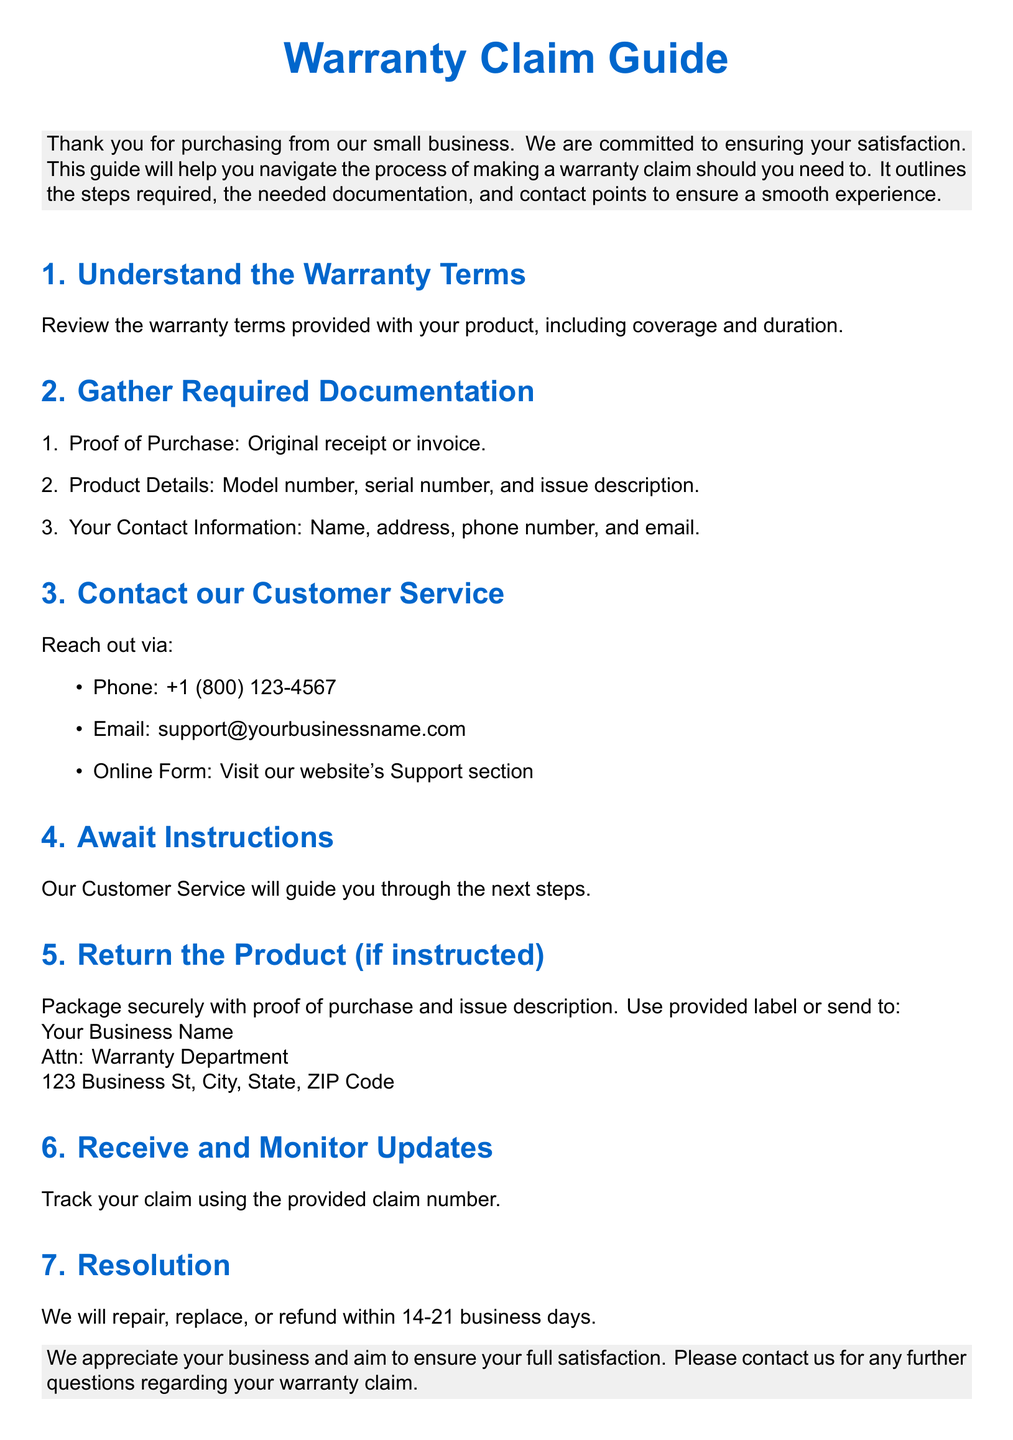What is the first step in making a warranty claim? The first step in making a warranty claim is to review the warranty terms provided with your product.
Answer: Understand the Warranty Terms What contact methods are provided for customer service? The document lists phone, email, and an online form as contact methods for customer service.
Answer: Phone, Email, Online Form How long will it take to receive a resolution to the claim? The document states that the resolution will be provided within 14-21 business days after the claim is submitted.
Answer: 14-21 business days What information is included in the required documentation? The required documentation includes proof of purchase, product details, and your contact information.
Answer: Proof of Purchase, Product Details, Your Contact Information Where should the product be sent if instructed to return it? The product should be sent to the address provided for the Warranty Department, which includes the business name and address.
Answer: Your Business Name, Attn: Warranty Department, 123 Business St, City, State, ZIP Code What is included in the product details needed for documentation? The product details needed for documentation include the model number, serial number, and issue description.
Answer: Model number, serial number, issue description What should you do after contacting customer service? After contacting customer service, you should await instructions on the next steps to take regarding your claim.
Answer: Await Instructions What is the purpose of this document? The purpose of the document is to help customers navigate the process of making a warranty claim.
Answer: Help customers navigate warranty claims 